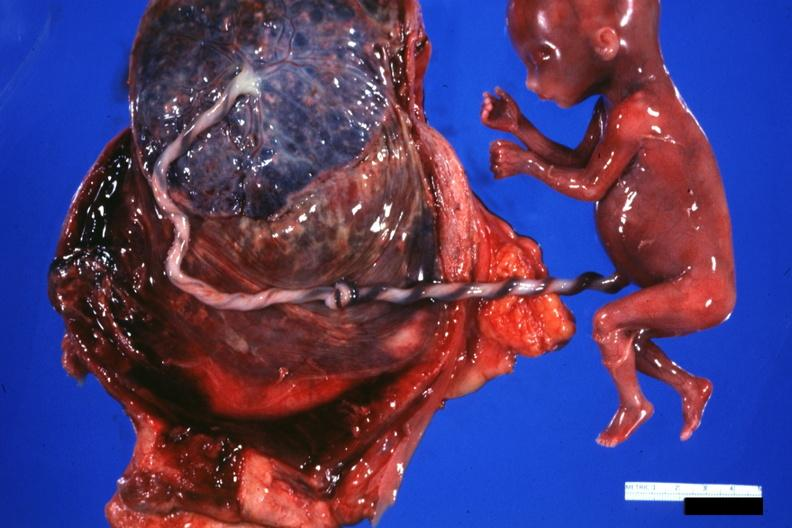s carcinoma present?
Answer the question using a single word or phrase. No 